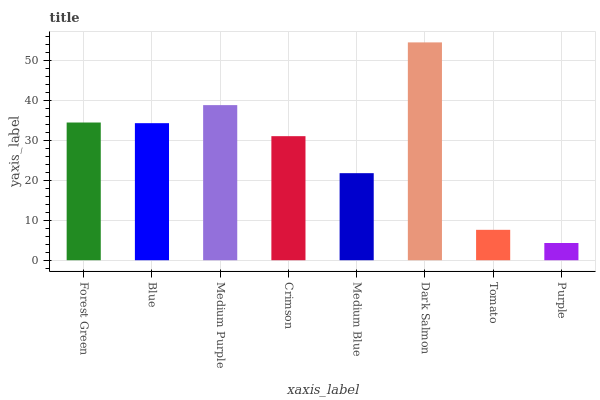Is Purple the minimum?
Answer yes or no. Yes. Is Dark Salmon the maximum?
Answer yes or no. Yes. Is Blue the minimum?
Answer yes or no. No. Is Blue the maximum?
Answer yes or no. No. Is Forest Green greater than Blue?
Answer yes or no. Yes. Is Blue less than Forest Green?
Answer yes or no. Yes. Is Blue greater than Forest Green?
Answer yes or no. No. Is Forest Green less than Blue?
Answer yes or no. No. Is Blue the high median?
Answer yes or no. Yes. Is Crimson the low median?
Answer yes or no. Yes. Is Medium Blue the high median?
Answer yes or no. No. Is Forest Green the low median?
Answer yes or no. No. 